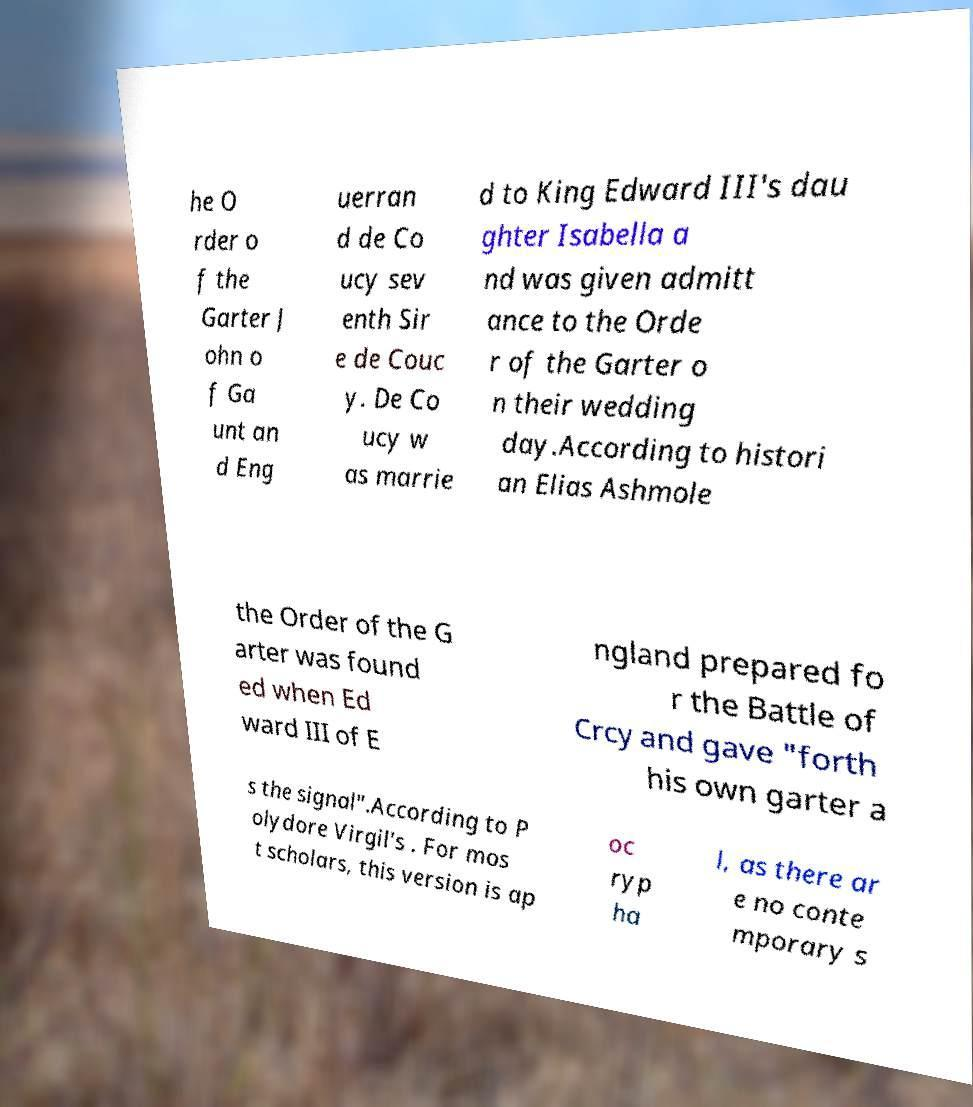I need the written content from this picture converted into text. Can you do that? he O rder o f the Garter J ohn o f Ga unt an d Eng uerran d de Co ucy sev enth Sir e de Couc y. De Co ucy w as marrie d to King Edward III's dau ghter Isabella a nd was given admitt ance to the Orde r of the Garter o n their wedding day.According to histori an Elias Ashmole the Order of the G arter was found ed when Ed ward III of E ngland prepared fo r the Battle of Crcy and gave "forth his own garter a s the signal".According to P olydore Virgil's . For mos t scholars, this version is ap oc ryp ha l, as there ar e no conte mporary s 